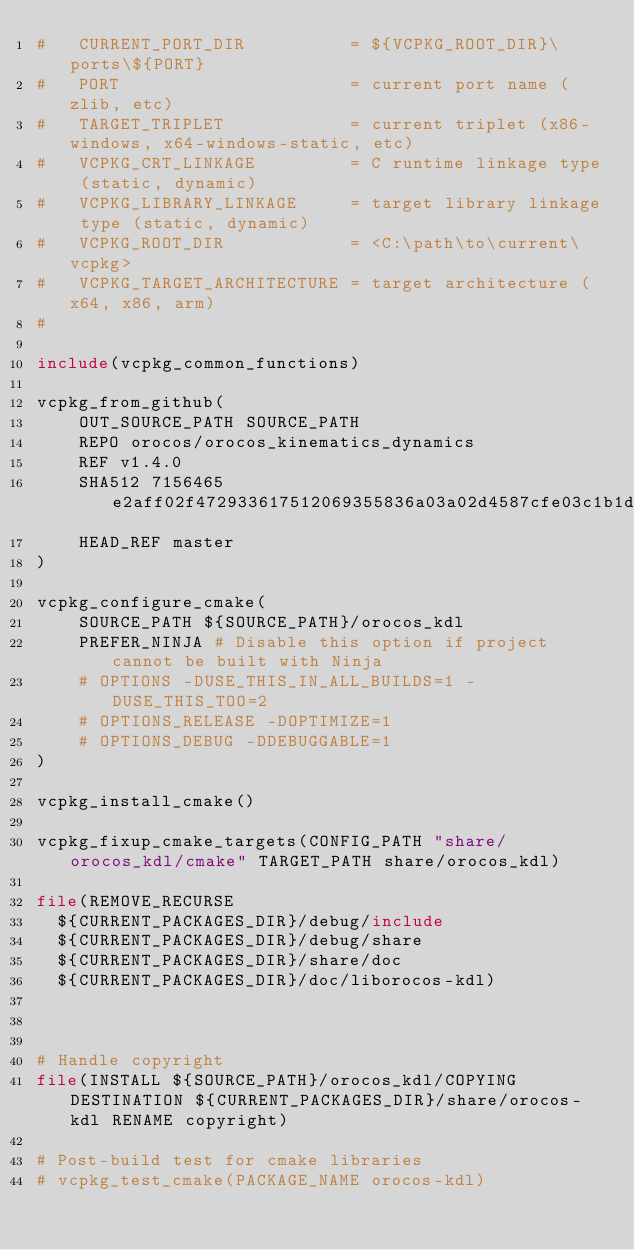<code> <loc_0><loc_0><loc_500><loc_500><_CMake_>#   CURRENT_PORT_DIR          = ${VCPKG_ROOT_DIR}\ports\${PORT}
#   PORT                      = current port name (zlib, etc)
#   TARGET_TRIPLET            = current triplet (x86-windows, x64-windows-static, etc)
#   VCPKG_CRT_LINKAGE         = C runtime linkage type (static, dynamic)
#   VCPKG_LIBRARY_LINKAGE     = target library linkage type (static, dynamic)
#   VCPKG_ROOT_DIR            = <C:\path\to\current\vcpkg>
#   VCPKG_TARGET_ARCHITECTURE = target architecture (x64, x86, arm)
#

include(vcpkg_common_functions)

vcpkg_from_github(
    OUT_SOURCE_PATH SOURCE_PATH
    REPO orocos/orocos_kinematics_dynamics
    REF v1.4.0
    SHA512 7156465e2aff02f472933617512069355836a03a02d4587cfe03c1b1d667a9762a4e3ed6e055b2a44f1fce1b6746179203c7204389626a7b458dcab1b28930d8
    HEAD_REF master
)

vcpkg_configure_cmake(
    SOURCE_PATH ${SOURCE_PATH}/orocos_kdl
    PREFER_NINJA # Disable this option if project cannot be built with Ninja
    # OPTIONS -DUSE_THIS_IN_ALL_BUILDS=1 -DUSE_THIS_TOO=2
    # OPTIONS_RELEASE -DOPTIMIZE=1
    # OPTIONS_DEBUG -DDEBUGGABLE=1
)

vcpkg_install_cmake()

vcpkg_fixup_cmake_targets(CONFIG_PATH "share/orocos_kdl/cmake" TARGET_PATH share/orocos_kdl)

file(REMOVE_RECURSE 
  ${CURRENT_PACKAGES_DIR}/debug/include
  ${CURRENT_PACKAGES_DIR}/debug/share
  ${CURRENT_PACKAGES_DIR}/share/doc
  ${CURRENT_PACKAGES_DIR}/doc/liborocos-kdl)
  


# Handle copyright
file(INSTALL ${SOURCE_PATH}/orocos_kdl/COPYING DESTINATION ${CURRENT_PACKAGES_DIR}/share/orocos-kdl RENAME copyright)

# Post-build test for cmake libraries
# vcpkg_test_cmake(PACKAGE_NAME orocos-kdl)
</code> 